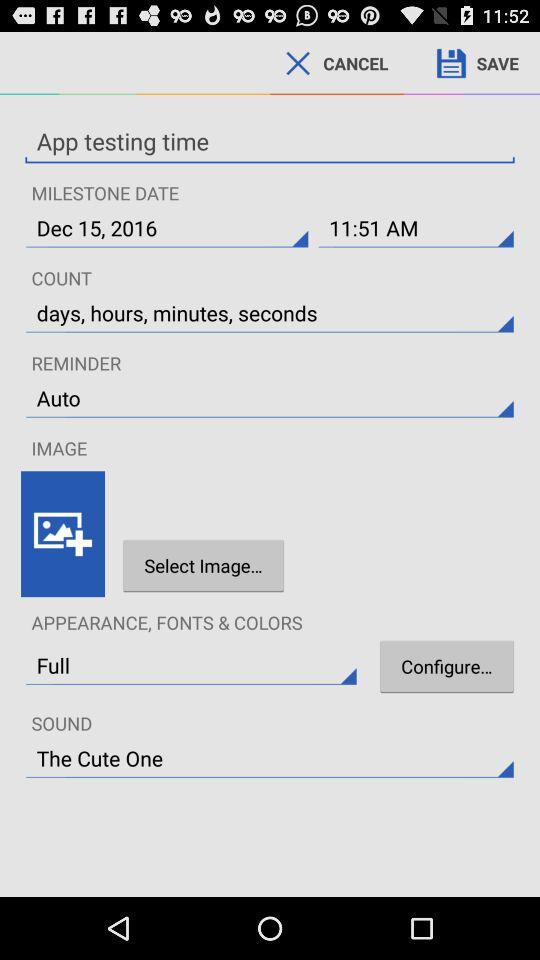What is the setting for reminder? The setting for reminder is "Auto". 